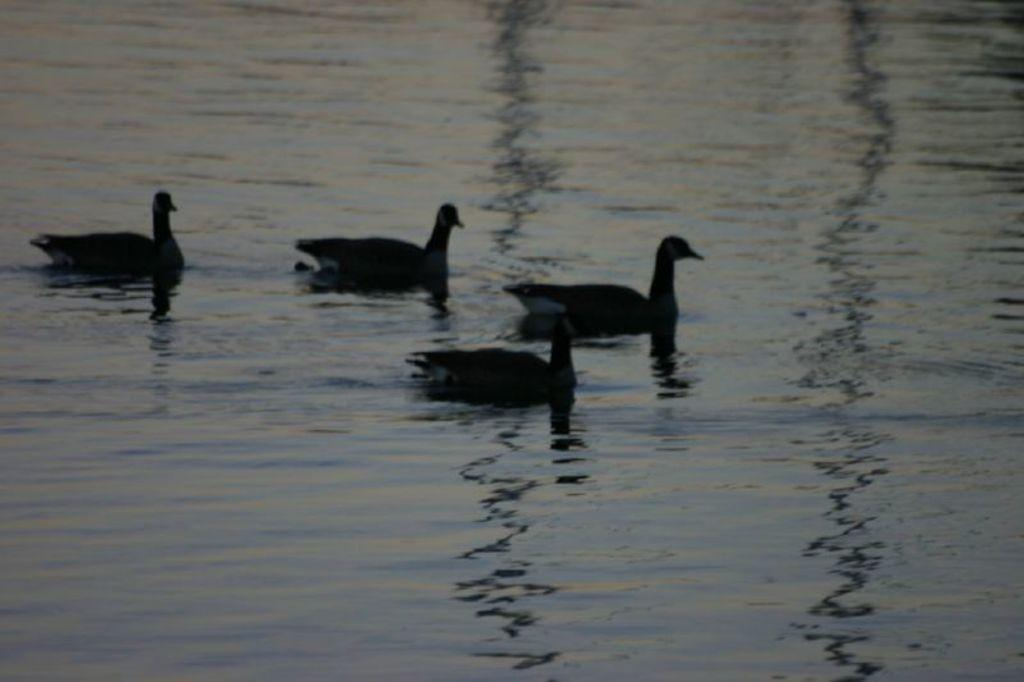How many ducks are present in the image? There are four ducks in the image. What are the ducks doing in the image? The ducks are floating on the water. Where is the shop located in the image? There is no shop present in the image; it features four ducks floating on the water. What type of bread can be seen in the image? There is no bread present in the image. 